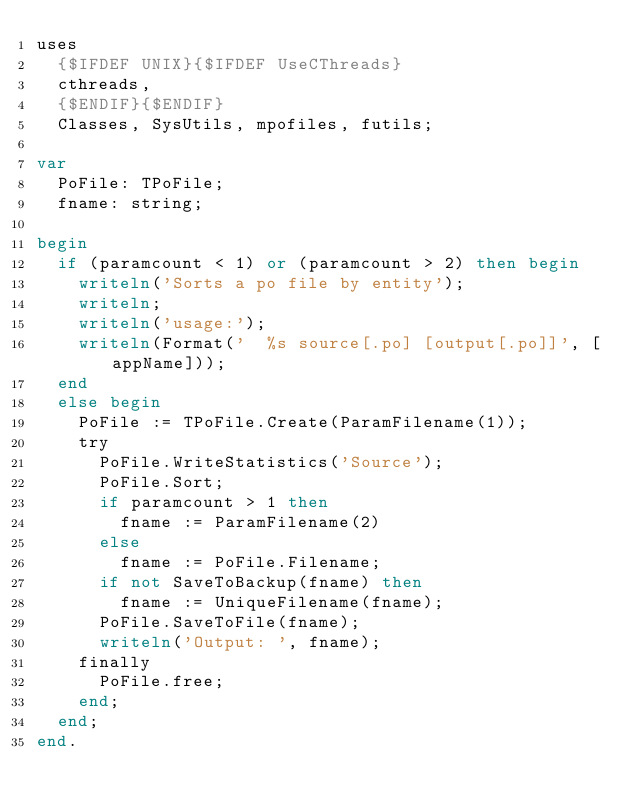<code> <loc_0><loc_0><loc_500><loc_500><_Pascal_>uses
  {$IFDEF UNIX}{$IFDEF UseCThreads}
  cthreads,
  {$ENDIF}{$ENDIF}
  Classes, SysUtils, mpofiles, futils;

var
  PoFile: TPoFile;
  fname: string;

begin
  if (paramcount < 1) or (paramcount > 2) then begin
    writeln('Sorts a po file by entity');
    writeln;
    writeln('usage:');
    writeln(Format('  %s source[.po] [output[.po]]', [appName]));
  end
  else begin
    PoFile := TPoFile.Create(ParamFilename(1));
    try
      PoFile.WriteStatistics('Source');
      PoFile.Sort;
      if paramcount > 1 then
        fname := ParamFilename(2)
      else
        fname := PoFile.Filename;
      if not SaveToBackup(fname) then
        fname := UniqueFilename(fname);
      PoFile.SaveToFile(fname);
      writeln('Output: ', fname);
    finally
      PoFile.free;
    end;
  end;
end.

</code> 